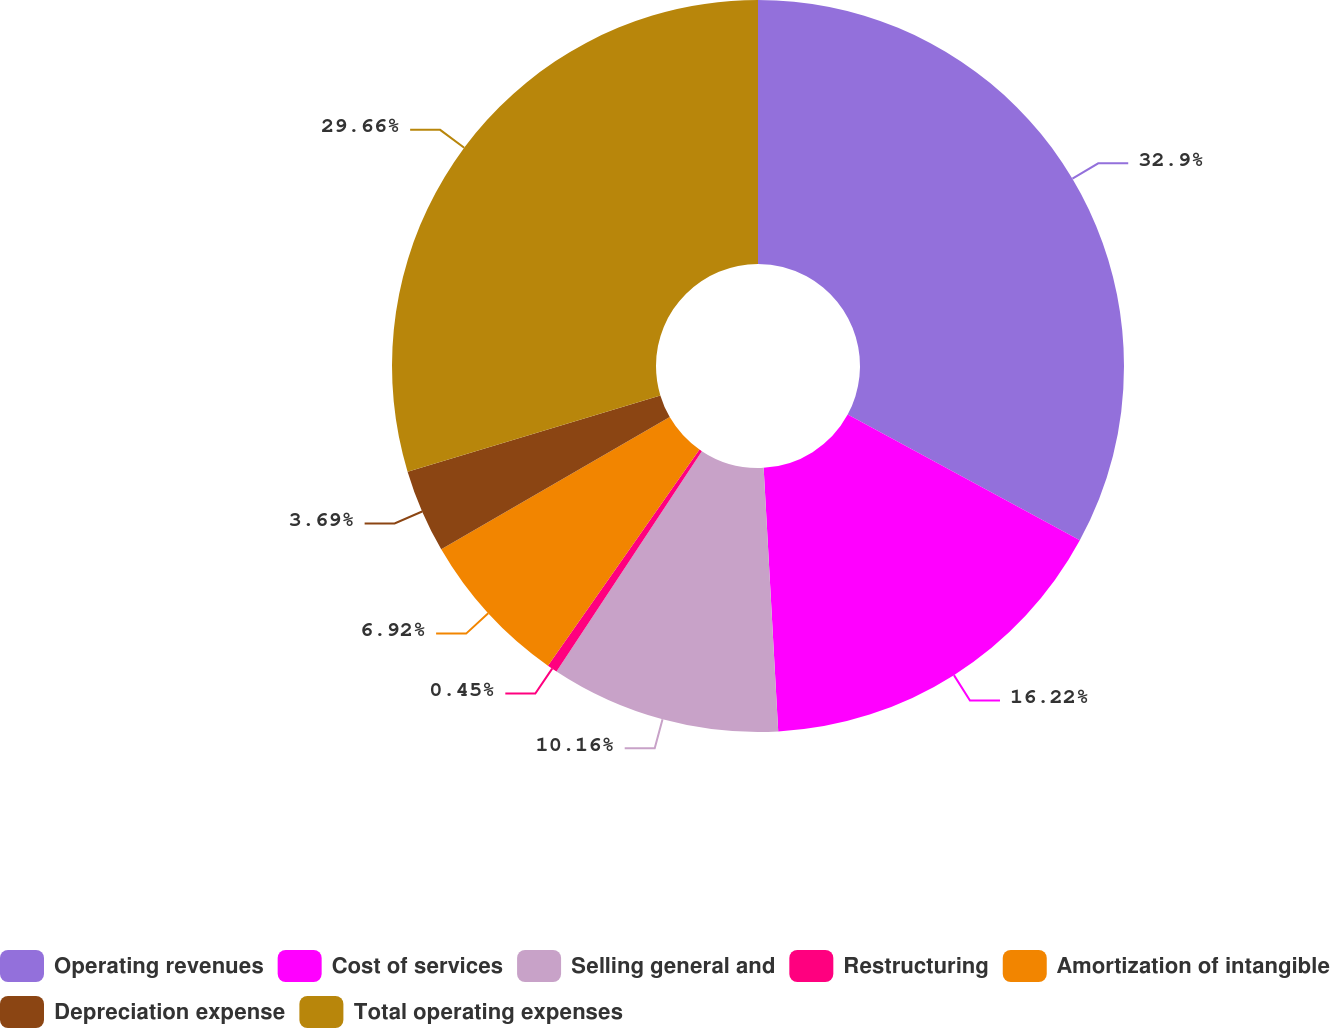Convert chart to OTSL. <chart><loc_0><loc_0><loc_500><loc_500><pie_chart><fcel>Operating revenues<fcel>Cost of services<fcel>Selling general and<fcel>Restructuring<fcel>Amortization of intangible<fcel>Depreciation expense<fcel>Total operating expenses<nl><fcel>32.9%<fcel>16.22%<fcel>10.16%<fcel>0.45%<fcel>6.92%<fcel>3.69%<fcel>29.66%<nl></chart> 